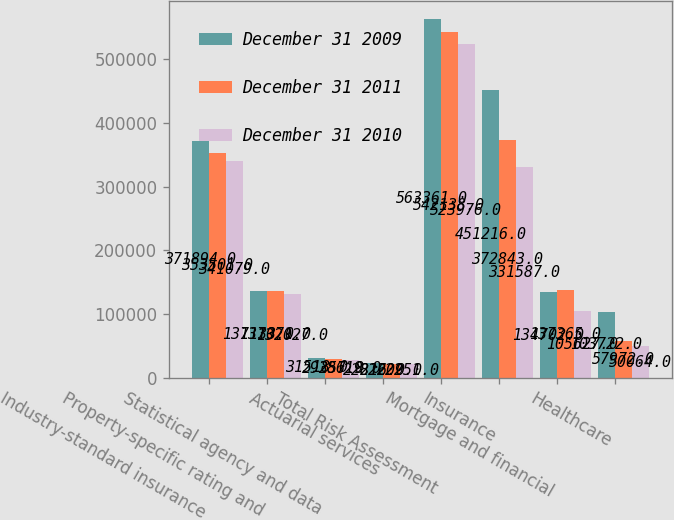<chart> <loc_0><loc_0><loc_500><loc_500><stacked_bar_chart><ecel><fcel>Industry-standard insurance<fcel>Property-specific rating and<fcel>Statistical agency and data<fcel>Actuarial services<fcel>Total Risk Assessment<fcel>Insurance<fcel>Mortgage and financial<fcel>Healthcare<nl><fcel>December 31 2009<fcel>371894<fcel>137133<fcel>31518<fcel>22816<fcel>563361<fcel>451216<fcel>134702<fcel>103722<nl><fcel>December 31 2011<fcel>353501<fcel>137071<fcel>29357<fcel>22209<fcel>542138<fcel>372843<fcel>137365<fcel>57972<nl><fcel>December 31 2010<fcel>341079<fcel>132027<fcel>28619<fcel>22251<fcel>523976<fcel>331587<fcel>105627<fcel>50064<nl></chart> 